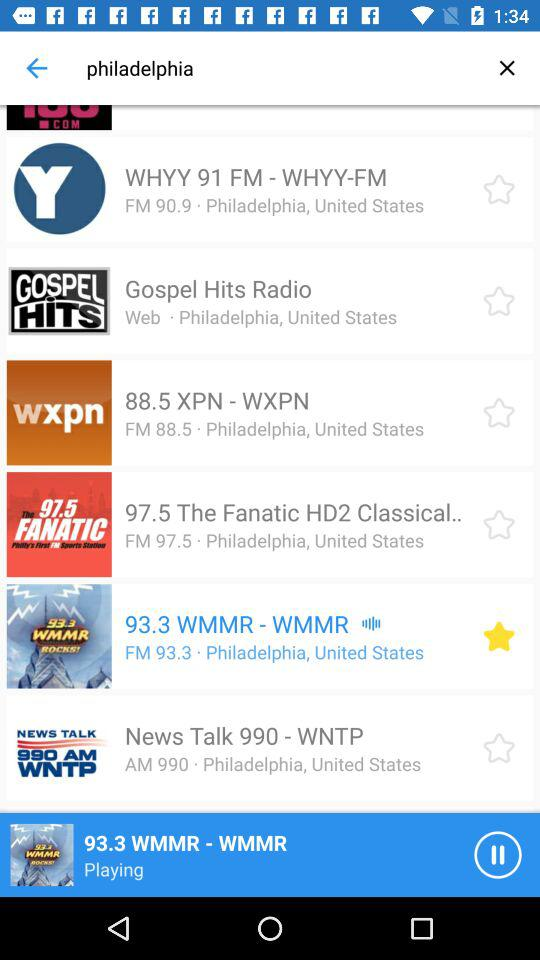Which radio station is highlighted? The highlighted radio station is "WMMR". 